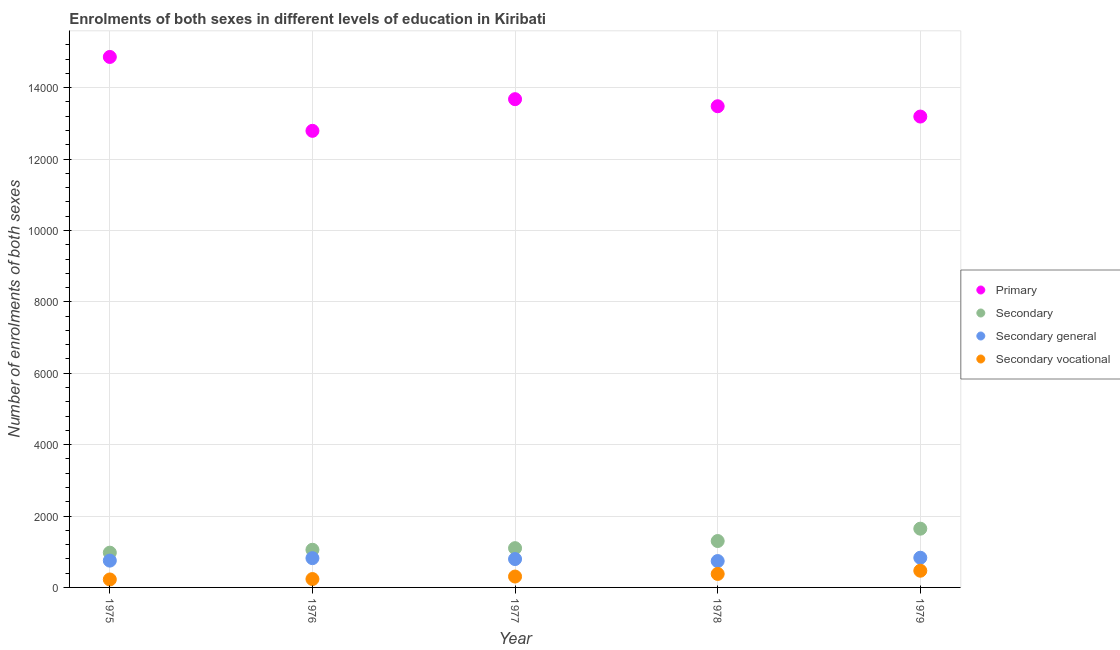What is the number of enrolments in secondary vocational education in 1977?
Your response must be concise. 305. Across all years, what is the maximum number of enrolments in primary education?
Provide a succinct answer. 1.49e+04. Across all years, what is the minimum number of enrolments in secondary general education?
Give a very brief answer. 739. In which year was the number of enrolments in secondary general education maximum?
Keep it short and to the point. 1979. In which year was the number of enrolments in primary education minimum?
Offer a very short reply. 1976. What is the total number of enrolments in primary education in the graph?
Offer a very short reply. 6.80e+04. What is the difference between the number of enrolments in secondary vocational education in 1975 and that in 1978?
Make the answer very short. -155. What is the difference between the number of enrolments in secondary vocational education in 1979 and the number of enrolments in secondary education in 1976?
Offer a terse response. -587. What is the average number of enrolments in secondary general education per year?
Make the answer very short. 787.4. In the year 1977, what is the difference between the number of enrolments in secondary education and number of enrolments in secondary general education?
Your response must be concise. 305. In how many years, is the number of enrolments in secondary general education greater than 9600?
Keep it short and to the point. 0. What is the ratio of the number of enrolments in secondary general education in 1976 to that in 1978?
Make the answer very short. 1.11. Is the difference between the number of enrolments in secondary general education in 1977 and 1979 greater than the difference between the number of enrolments in primary education in 1977 and 1979?
Provide a succinct answer. No. What is the difference between the highest and the second highest number of enrolments in secondary vocational education?
Make the answer very short. 90. What is the difference between the highest and the lowest number of enrolments in secondary vocational education?
Ensure brevity in your answer.  245. In how many years, is the number of enrolments in secondary vocational education greater than the average number of enrolments in secondary vocational education taken over all years?
Your response must be concise. 2. Is it the case that in every year, the sum of the number of enrolments in secondary general education and number of enrolments in secondary education is greater than the sum of number of enrolments in primary education and number of enrolments in secondary vocational education?
Your answer should be very brief. No. Is it the case that in every year, the sum of the number of enrolments in primary education and number of enrolments in secondary education is greater than the number of enrolments in secondary general education?
Give a very brief answer. Yes. Does the number of enrolments in secondary vocational education monotonically increase over the years?
Provide a short and direct response. Yes. Is the number of enrolments in secondary general education strictly less than the number of enrolments in secondary vocational education over the years?
Make the answer very short. No. Are the values on the major ticks of Y-axis written in scientific E-notation?
Keep it short and to the point. No. Does the graph contain grids?
Your answer should be compact. Yes. Where does the legend appear in the graph?
Give a very brief answer. Center right. What is the title of the graph?
Make the answer very short. Enrolments of both sexes in different levels of education in Kiribati. Does "Social Awareness" appear as one of the legend labels in the graph?
Your response must be concise. No. What is the label or title of the X-axis?
Ensure brevity in your answer.  Year. What is the label or title of the Y-axis?
Provide a short and direct response. Number of enrolments of both sexes. What is the Number of enrolments of both sexes in Primary in 1975?
Provide a succinct answer. 1.49e+04. What is the Number of enrolments of both sexes in Secondary in 1975?
Keep it short and to the point. 974. What is the Number of enrolments of both sexes of Secondary general in 1975?
Your response must be concise. 751. What is the Number of enrolments of both sexes in Secondary vocational in 1975?
Offer a very short reply. 223. What is the Number of enrolments of both sexes of Primary in 1976?
Keep it short and to the point. 1.28e+04. What is the Number of enrolments of both sexes in Secondary in 1976?
Your response must be concise. 1055. What is the Number of enrolments of both sexes in Secondary general in 1976?
Keep it short and to the point. 820. What is the Number of enrolments of both sexes in Secondary vocational in 1976?
Keep it short and to the point. 235. What is the Number of enrolments of both sexes in Primary in 1977?
Provide a short and direct response. 1.37e+04. What is the Number of enrolments of both sexes in Secondary in 1977?
Keep it short and to the point. 1100. What is the Number of enrolments of both sexes in Secondary general in 1977?
Your answer should be very brief. 795. What is the Number of enrolments of both sexes in Secondary vocational in 1977?
Give a very brief answer. 305. What is the Number of enrolments of both sexes in Primary in 1978?
Give a very brief answer. 1.35e+04. What is the Number of enrolments of both sexes in Secondary in 1978?
Offer a terse response. 1300. What is the Number of enrolments of both sexes of Secondary general in 1978?
Your response must be concise. 739. What is the Number of enrolments of both sexes of Secondary vocational in 1978?
Offer a very short reply. 378. What is the Number of enrolments of both sexes in Primary in 1979?
Give a very brief answer. 1.32e+04. What is the Number of enrolments of both sexes in Secondary in 1979?
Make the answer very short. 1646. What is the Number of enrolments of both sexes of Secondary general in 1979?
Provide a short and direct response. 832. What is the Number of enrolments of both sexes of Secondary vocational in 1979?
Offer a terse response. 468. Across all years, what is the maximum Number of enrolments of both sexes in Primary?
Your response must be concise. 1.49e+04. Across all years, what is the maximum Number of enrolments of both sexes of Secondary?
Your response must be concise. 1646. Across all years, what is the maximum Number of enrolments of both sexes in Secondary general?
Your answer should be compact. 832. Across all years, what is the maximum Number of enrolments of both sexes of Secondary vocational?
Offer a very short reply. 468. Across all years, what is the minimum Number of enrolments of both sexes of Primary?
Provide a succinct answer. 1.28e+04. Across all years, what is the minimum Number of enrolments of both sexes in Secondary?
Make the answer very short. 974. Across all years, what is the minimum Number of enrolments of both sexes of Secondary general?
Give a very brief answer. 739. Across all years, what is the minimum Number of enrolments of both sexes of Secondary vocational?
Give a very brief answer. 223. What is the total Number of enrolments of both sexes of Primary in the graph?
Provide a short and direct response. 6.80e+04. What is the total Number of enrolments of both sexes of Secondary in the graph?
Offer a very short reply. 6075. What is the total Number of enrolments of both sexes in Secondary general in the graph?
Provide a succinct answer. 3937. What is the total Number of enrolments of both sexes in Secondary vocational in the graph?
Ensure brevity in your answer.  1609. What is the difference between the Number of enrolments of both sexes of Primary in 1975 and that in 1976?
Make the answer very short. 2070. What is the difference between the Number of enrolments of both sexes of Secondary in 1975 and that in 1976?
Make the answer very short. -81. What is the difference between the Number of enrolments of both sexes of Secondary general in 1975 and that in 1976?
Offer a very short reply. -69. What is the difference between the Number of enrolments of both sexes in Primary in 1975 and that in 1977?
Provide a short and direct response. 1183. What is the difference between the Number of enrolments of both sexes in Secondary in 1975 and that in 1977?
Provide a short and direct response. -126. What is the difference between the Number of enrolments of both sexes of Secondary general in 1975 and that in 1977?
Offer a very short reply. -44. What is the difference between the Number of enrolments of both sexes in Secondary vocational in 1975 and that in 1977?
Your answer should be compact. -82. What is the difference between the Number of enrolments of both sexes of Primary in 1975 and that in 1978?
Your answer should be very brief. 1381. What is the difference between the Number of enrolments of both sexes of Secondary in 1975 and that in 1978?
Provide a succinct answer. -326. What is the difference between the Number of enrolments of both sexes of Secondary vocational in 1975 and that in 1978?
Ensure brevity in your answer.  -155. What is the difference between the Number of enrolments of both sexes of Primary in 1975 and that in 1979?
Keep it short and to the point. 1670. What is the difference between the Number of enrolments of both sexes of Secondary in 1975 and that in 1979?
Keep it short and to the point. -672. What is the difference between the Number of enrolments of both sexes in Secondary general in 1975 and that in 1979?
Give a very brief answer. -81. What is the difference between the Number of enrolments of both sexes of Secondary vocational in 1975 and that in 1979?
Your answer should be compact. -245. What is the difference between the Number of enrolments of both sexes of Primary in 1976 and that in 1977?
Offer a very short reply. -887. What is the difference between the Number of enrolments of both sexes of Secondary in 1976 and that in 1977?
Your answer should be compact. -45. What is the difference between the Number of enrolments of both sexes in Secondary general in 1976 and that in 1977?
Provide a succinct answer. 25. What is the difference between the Number of enrolments of both sexes in Secondary vocational in 1976 and that in 1977?
Provide a succinct answer. -70. What is the difference between the Number of enrolments of both sexes in Primary in 1976 and that in 1978?
Offer a very short reply. -689. What is the difference between the Number of enrolments of both sexes in Secondary in 1976 and that in 1978?
Your answer should be very brief. -245. What is the difference between the Number of enrolments of both sexes of Secondary vocational in 1976 and that in 1978?
Keep it short and to the point. -143. What is the difference between the Number of enrolments of both sexes in Primary in 1976 and that in 1979?
Offer a terse response. -400. What is the difference between the Number of enrolments of both sexes in Secondary in 1976 and that in 1979?
Ensure brevity in your answer.  -591. What is the difference between the Number of enrolments of both sexes in Secondary general in 1976 and that in 1979?
Provide a short and direct response. -12. What is the difference between the Number of enrolments of both sexes of Secondary vocational in 1976 and that in 1979?
Keep it short and to the point. -233. What is the difference between the Number of enrolments of both sexes of Primary in 1977 and that in 1978?
Offer a very short reply. 198. What is the difference between the Number of enrolments of both sexes of Secondary in 1977 and that in 1978?
Your answer should be compact. -200. What is the difference between the Number of enrolments of both sexes in Secondary vocational in 1977 and that in 1978?
Offer a terse response. -73. What is the difference between the Number of enrolments of both sexes of Primary in 1977 and that in 1979?
Your answer should be compact. 487. What is the difference between the Number of enrolments of both sexes in Secondary in 1977 and that in 1979?
Give a very brief answer. -546. What is the difference between the Number of enrolments of both sexes in Secondary general in 1977 and that in 1979?
Your answer should be very brief. -37. What is the difference between the Number of enrolments of both sexes in Secondary vocational in 1977 and that in 1979?
Give a very brief answer. -163. What is the difference between the Number of enrolments of both sexes of Primary in 1978 and that in 1979?
Provide a short and direct response. 289. What is the difference between the Number of enrolments of both sexes in Secondary in 1978 and that in 1979?
Provide a short and direct response. -346. What is the difference between the Number of enrolments of both sexes in Secondary general in 1978 and that in 1979?
Your answer should be very brief. -93. What is the difference between the Number of enrolments of both sexes in Secondary vocational in 1978 and that in 1979?
Your answer should be compact. -90. What is the difference between the Number of enrolments of both sexes of Primary in 1975 and the Number of enrolments of both sexes of Secondary in 1976?
Ensure brevity in your answer.  1.38e+04. What is the difference between the Number of enrolments of both sexes of Primary in 1975 and the Number of enrolments of both sexes of Secondary general in 1976?
Ensure brevity in your answer.  1.40e+04. What is the difference between the Number of enrolments of both sexes in Primary in 1975 and the Number of enrolments of both sexes in Secondary vocational in 1976?
Provide a short and direct response. 1.46e+04. What is the difference between the Number of enrolments of both sexes in Secondary in 1975 and the Number of enrolments of both sexes in Secondary general in 1976?
Make the answer very short. 154. What is the difference between the Number of enrolments of both sexes in Secondary in 1975 and the Number of enrolments of both sexes in Secondary vocational in 1976?
Make the answer very short. 739. What is the difference between the Number of enrolments of both sexes in Secondary general in 1975 and the Number of enrolments of both sexes in Secondary vocational in 1976?
Provide a short and direct response. 516. What is the difference between the Number of enrolments of both sexes of Primary in 1975 and the Number of enrolments of both sexes of Secondary in 1977?
Offer a very short reply. 1.38e+04. What is the difference between the Number of enrolments of both sexes of Primary in 1975 and the Number of enrolments of both sexes of Secondary general in 1977?
Give a very brief answer. 1.41e+04. What is the difference between the Number of enrolments of both sexes in Primary in 1975 and the Number of enrolments of both sexes in Secondary vocational in 1977?
Give a very brief answer. 1.46e+04. What is the difference between the Number of enrolments of both sexes in Secondary in 1975 and the Number of enrolments of both sexes in Secondary general in 1977?
Your answer should be compact. 179. What is the difference between the Number of enrolments of both sexes in Secondary in 1975 and the Number of enrolments of both sexes in Secondary vocational in 1977?
Provide a succinct answer. 669. What is the difference between the Number of enrolments of both sexes in Secondary general in 1975 and the Number of enrolments of both sexes in Secondary vocational in 1977?
Your answer should be very brief. 446. What is the difference between the Number of enrolments of both sexes of Primary in 1975 and the Number of enrolments of both sexes of Secondary in 1978?
Provide a succinct answer. 1.36e+04. What is the difference between the Number of enrolments of both sexes of Primary in 1975 and the Number of enrolments of both sexes of Secondary general in 1978?
Your answer should be very brief. 1.41e+04. What is the difference between the Number of enrolments of both sexes in Primary in 1975 and the Number of enrolments of both sexes in Secondary vocational in 1978?
Offer a very short reply. 1.45e+04. What is the difference between the Number of enrolments of both sexes of Secondary in 1975 and the Number of enrolments of both sexes of Secondary general in 1978?
Give a very brief answer. 235. What is the difference between the Number of enrolments of both sexes in Secondary in 1975 and the Number of enrolments of both sexes in Secondary vocational in 1978?
Your response must be concise. 596. What is the difference between the Number of enrolments of both sexes in Secondary general in 1975 and the Number of enrolments of both sexes in Secondary vocational in 1978?
Your response must be concise. 373. What is the difference between the Number of enrolments of both sexes in Primary in 1975 and the Number of enrolments of both sexes in Secondary in 1979?
Offer a terse response. 1.32e+04. What is the difference between the Number of enrolments of both sexes in Primary in 1975 and the Number of enrolments of both sexes in Secondary general in 1979?
Make the answer very short. 1.40e+04. What is the difference between the Number of enrolments of both sexes of Primary in 1975 and the Number of enrolments of both sexes of Secondary vocational in 1979?
Make the answer very short. 1.44e+04. What is the difference between the Number of enrolments of both sexes in Secondary in 1975 and the Number of enrolments of both sexes in Secondary general in 1979?
Keep it short and to the point. 142. What is the difference between the Number of enrolments of both sexes in Secondary in 1975 and the Number of enrolments of both sexes in Secondary vocational in 1979?
Offer a very short reply. 506. What is the difference between the Number of enrolments of both sexes of Secondary general in 1975 and the Number of enrolments of both sexes of Secondary vocational in 1979?
Keep it short and to the point. 283. What is the difference between the Number of enrolments of both sexes of Primary in 1976 and the Number of enrolments of both sexes of Secondary in 1977?
Ensure brevity in your answer.  1.17e+04. What is the difference between the Number of enrolments of both sexes in Primary in 1976 and the Number of enrolments of both sexes in Secondary general in 1977?
Keep it short and to the point. 1.20e+04. What is the difference between the Number of enrolments of both sexes of Primary in 1976 and the Number of enrolments of both sexes of Secondary vocational in 1977?
Ensure brevity in your answer.  1.25e+04. What is the difference between the Number of enrolments of both sexes in Secondary in 1976 and the Number of enrolments of both sexes in Secondary general in 1977?
Your answer should be very brief. 260. What is the difference between the Number of enrolments of both sexes in Secondary in 1976 and the Number of enrolments of both sexes in Secondary vocational in 1977?
Provide a succinct answer. 750. What is the difference between the Number of enrolments of both sexes of Secondary general in 1976 and the Number of enrolments of both sexes of Secondary vocational in 1977?
Your answer should be compact. 515. What is the difference between the Number of enrolments of both sexes of Primary in 1976 and the Number of enrolments of both sexes of Secondary in 1978?
Your response must be concise. 1.15e+04. What is the difference between the Number of enrolments of both sexes of Primary in 1976 and the Number of enrolments of both sexes of Secondary general in 1978?
Provide a short and direct response. 1.21e+04. What is the difference between the Number of enrolments of both sexes in Primary in 1976 and the Number of enrolments of both sexes in Secondary vocational in 1978?
Make the answer very short. 1.24e+04. What is the difference between the Number of enrolments of both sexes in Secondary in 1976 and the Number of enrolments of both sexes in Secondary general in 1978?
Offer a very short reply. 316. What is the difference between the Number of enrolments of both sexes of Secondary in 1976 and the Number of enrolments of both sexes of Secondary vocational in 1978?
Ensure brevity in your answer.  677. What is the difference between the Number of enrolments of both sexes in Secondary general in 1976 and the Number of enrolments of both sexes in Secondary vocational in 1978?
Give a very brief answer. 442. What is the difference between the Number of enrolments of both sexes in Primary in 1976 and the Number of enrolments of both sexes in Secondary in 1979?
Provide a short and direct response. 1.11e+04. What is the difference between the Number of enrolments of both sexes of Primary in 1976 and the Number of enrolments of both sexes of Secondary general in 1979?
Give a very brief answer. 1.20e+04. What is the difference between the Number of enrolments of both sexes in Primary in 1976 and the Number of enrolments of both sexes in Secondary vocational in 1979?
Ensure brevity in your answer.  1.23e+04. What is the difference between the Number of enrolments of both sexes of Secondary in 1976 and the Number of enrolments of both sexes of Secondary general in 1979?
Offer a very short reply. 223. What is the difference between the Number of enrolments of both sexes of Secondary in 1976 and the Number of enrolments of both sexes of Secondary vocational in 1979?
Offer a very short reply. 587. What is the difference between the Number of enrolments of both sexes in Secondary general in 1976 and the Number of enrolments of both sexes in Secondary vocational in 1979?
Provide a succinct answer. 352. What is the difference between the Number of enrolments of both sexes in Primary in 1977 and the Number of enrolments of both sexes in Secondary in 1978?
Offer a terse response. 1.24e+04. What is the difference between the Number of enrolments of both sexes of Primary in 1977 and the Number of enrolments of both sexes of Secondary general in 1978?
Make the answer very short. 1.29e+04. What is the difference between the Number of enrolments of both sexes in Primary in 1977 and the Number of enrolments of both sexes in Secondary vocational in 1978?
Keep it short and to the point. 1.33e+04. What is the difference between the Number of enrolments of both sexes in Secondary in 1977 and the Number of enrolments of both sexes in Secondary general in 1978?
Make the answer very short. 361. What is the difference between the Number of enrolments of both sexes of Secondary in 1977 and the Number of enrolments of both sexes of Secondary vocational in 1978?
Keep it short and to the point. 722. What is the difference between the Number of enrolments of both sexes in Secondary general in 1977 and the Number of enrolments of both sexes in Secondary vocational in 1978?
Make the answer very short. 417. What is the difference between the Number of enrolments of both sexes in Primary in 1977 and the Number of enrolments of both sexes in Secondary in 1979?
Offer a very short reply. 1.20e+04. What is the difference between the Number of enrolments of both sexes in Primary in 1977 and the Number of enrolments of both sexes in Secondary general in 1979?
Your answer should be compact. 1.28e+04. What is the difference between the Number of enrolments of both sexes of Primary in 1977 and the Number of enrolments of both sexes of Secondary vocational in 1979?
Offer a terse response. 1.32e+04. What is the difference between the Number of enrolments of both sexes of Secondary in 1977 and the Number of enrolments of both sexes of Secondary general in 1979?
Give a very brief answer. 268. What is the difference between the Number of enrolments of both sexes of Secondary in 1977 and the Number of enrolments of both sexes of Secondary vocational in 1979?
Offer a terse response. 632. What is the difference between the Number of enrolments of both sexes in Secondary general in 1977 and the Number of enrolments of both sexes in Secondary vocational in 1979?
Your response must be concise. 327. What is the difference between the Number of enrolments of both sexes of Primary in 1978 and the Number of enrolments of both sexes of Secondary in 1979?
Keep it short and to the point. 1.18e+04. What is the difference between the Number of enrolments of both sexes in Primary in 1978 and the Number of enrolments of both sexes in Secondary general in 1979?
Provide a succinct answer. 1.26e+04. What is the difference between the Number of enrolments of both sexes of Primary in 1978 and the Number of enrolments of both sexes of Secondary vocational in 1979?
Provide a succinct answer. 1.30e+04. What is the difference between the Number of enrolments of both sexes in Secondary in 1978 and the Number of enrolments of both sexes in Secondary general in 1979?
Offer a very short reply. 468. What is the difference between the Number of enrolments of both sexes in Secondary in 1978 and the Number of enrolments of both sexes in Secondary vocational in 1979?
Offer a terse response. 832. What is the difference between the Number of enrolments of both sexes of Secondary general in 1978 and the Number of enrolments of both sexes of Secondary vocational in 1979?
Make the answer very short. 271. What is the average Number of enrolments of both sexes of Primary per year?
Offer a very short reply. 1.36e+04. What is the average Number of enrolments of both sexes in Secondary per year?
Your response must be concise. 1215. What is the average Number of enrolments of both sexes in Secondary general per year?
Keep it short and to the point. 787.4. What is the average Number of enrolments of both sexes of Secondary vocational per year?
Your answer should be compact. 321.8. In the year 1975, what is the difference between the Number of enrolments of both sexes in Primary and Number of enrolments of both sexes in Secondary?
Provide a short and direct response. 1.39e+04. In the year 1975, what is the difference between the Number of enrolments of both sexes of Primary and Number of enrolments of both sexes of Secondary general?
Offer a very short reply. 1.41e+04. In the year 1975, what is the difference between the Number of enrolments of both sexes in Primary and Number of enrolments of both sexes in Secondary vocational?
Offer a very short reply. 1.46e+04. In the year 1975, what is the difference between the Number of enrolments of both sexes in Secondary and Number of enrolments of both sexes in Secondary general?
Your answer should be very brief. 223. In the year 1975, what is the difference between the Number of enrolments of both sexes of Secondary and Number of enrolments of both sexes of Secondary vocational?
Give a very brief answer. 751. In the year 1975, what is the difference between the Number of enrolments of both sexes of Secondary general and Number of enrolments of both sexes of Secondary vocational?
Keep it short and to the point. 528. In the year 1976, what is the difference between the Number of enrolments of both sexes in Primary and Number of enrolments of both sexes in Secondary?
Your answer should be very brief. 1.17e+04. In the year 1976, what is the difference between the Number of enrolments of both sexes in Primary and Number of enrolments of both sexes in Secondary general?
Provide a succinct answer. 1.20e+04. In the year 1976, what is the difference between the Number of enrolments of both sexes in Primary and Number of enrolments of both sexes in Secondary vocational?
Give a very brief answer. 1.26e+04. In the year 1976, what is the difference between the Number of enrolments of both sexes in Secondary and Number of enrolments of both sexes in Secondary general?
Provide a succinct answer. 235. In the year 1976, what is the difference between the Number of enrolments of both sexes of Secondary and Number of enrolments of both sexes of Secondary vocational?
Make the answer very short. 820. In the year 1976, what is the difference between the Number of enrolments of both sexes of Secondary general and Number of enrolments of both sexes of Secondary vocational?
Your answer should be compact. 585. In the year 1977, what is the difference between the Number of enrolments of both sexes in Primary and Number of enrolments of both sexes in Secondary?
Ensure brevity in your answer.  1.26e+04. In the year 1977, what is the difference between the Number of enrolments of both sexes of Primary and Number of enrolments of both sexes of Secondary general?
Make the answer very short. 1.29e+04. In the year 1977, what is the difference between the Number of enrolments of both sexes of Primary and Number of enrolments of both sexes of Secondary vocational?
Your response must be concise. 1.34e+04. In the year 1977, what is the difference between the Number of enrolments of both sexes in Secondary and Number of enrolments of both sexes in Secondary general?
Make the answer very short. 305. In the year 1977, what is the difference between the Number of enrolments of both sexes in Secondary and Number of enrolments of both sexes in Secondary vocational?
Keep it short and to the point. 795. In the year 1977, what is the difference between the Number of enrolments of both sexes in Secondary general and Number of enrolments of both sexes in Secondary vocational?
Provide a short and direct response. 490. In the year 1978, what is the difference between the Number of enrolments of both sexes in Primary and Number of enrolments of both sexes in Secondary?
Provide a succinct answer. 1.22e+04. In the year 1978, what is the difference between the Number of enrolments of both sexes of Primary and Number of enrolments of both sexes of Secondary general?
Provide a short and direct response. 1.27e+04. In the year 1978, what is the difference between the Number of enrolments of both sexes in Primary and Number of enrolments of both sexes in Secondary vocational?
Keep it short and to the point. 1.31e+04. In the year 1978, what is the difference between the Number of enrolments of both sexes of Secondary and Number of enrolments of both sexes of Secondary general?
Provide a short and direct response. 561. In the year 1978, what is the difference between the Number of enrolments of both sexes in Secondary and Number of enrolments of both sexes in Secondary vocational?
Offer a terse response. 922. In the year 1978, what is the difference between the Number of enrolments of both sexes in Secondary general and Number of enrolments of both sexes in Secondary vocational?
Keep it short and to the point. 361. In the year 1979, what is the difference between the Number of enrolments of both sexes of Primary and Number of enrolments of both sexes of Secondary?
Give a very brief answer. 1.15e+04. In the year 1979, what is the difference between the Number of enrolments of both sexes in Primary and Number of enrolments of both sexes in Secondary general?
Your answer should be compact. 1.24e+04. In the year 1979, what is the difference between the Number of enrolments of both sexes of Primary and Number of enrolments of both sexes of Secondary vocational?
Provide a succinct answer. 1.27e+04. In the year 1979, what is the difference between the Number of enrolments of both sexes in Secondary and Number of enrolments of both sexes in Secondary general?
Offer a very short reply. 814. In the year 1979, what is the difference between the Number of enrolments of both sexes of Secondary and Number of enrolments of both sexes of Secondary vocational?
Give a very brief answer. 1178. In the year 1979, what is the difference between the Number of enrolments of both sexes in Secondary general and Number of enrolments of both sexes in Secondary vocational?
Ensure brevity in your answer.  364. What is the ratio of the Number of enrolments of both sexes in Primary in 1975 to that in 1976?
Make the answer very short. 1.16. What is the ratio of the Number of enrolments of both sexes of Secondary in 1975 to that in 1976?
Make the answer very short. 0.92. What is the ratio of the Number of enrolments of both sexes of Secondary general in 1975 to that in 1976?
Provide a succinct answer. 0.92. What is the ratio of the Number of enrolments of both sexes in Secondary vocational in 1975 to that in 1976?
Your response must be concise. 0.95. What is the ratio of the Number of enrolments of both sexes in Primary in 1975 to that in 1977?
Offer a terse response. 1.09. What is the ratio of the Number of enrolments of both sexes in Secondary in 1975 to that in 1977?
Give a very brief answer. 0.89. What is the ratio of the Number of enrolments of both sexes in Secondary general in 1975 to that in 1977?
Keep it short and to the point. 0.94. What is the ratio of the Number of enrolments of both sexes in Secondary vocational in 1975 to that in 1977?
Your answer should be compact. 0.73. What is the ratio of the Number of enrolments of both sexes in Primary in 1975 to that in 1978?
Give a very brief answer. 1.1. What is the ratio of the Number of enrolments of both sexes of Secondary in 1975 to that in 1978?
Your response must be concise. 0.75. What is the ratio of the Number of enrolments of both sexes in Secondary general in 1975 to that in 1978?
Make the answer very short. 1.02. What is the ratio of the Number of enrolments of both sexes in Secondary vocational in 1975 to that in 1978?
Ensure brevity in your answer.  0.59. What is the ratio of the Number of enrolments of both sexes in Primary in 1975 to that in 1979?
Provide a short and direct response. 1.13. What is the ratio of the Number of enrolments of both sexes in Secondary in 1975 to that in 1979?
Your answer should be compact. 0.59. What is the ratio of the Number of enrolments of both sexes in Secondary general in 1975 to that in 1979?
Your answer should be very brief. 0.9. What is the ratio of the Number of enrolments of both sexes of Secondary vocational in 1975 to that in 1979?
Provide a short and direct response. 0.48. What is the ratio of the Number of enrolments of both sexes of Primary in 1976 to that in 1977?
Your response must be concise. 0.94. What is the ratio of the Number of enrolments of both sexes in Secondary in 1976 to that in 1977?
Your response must be concise. 0.96. What is the ratio of the Number of enrolments of both sexes of Secondary general in 1976 to that in 1977?
Your response must be concise. 1.03. What is the ratio of the Number of enrolments of both sexes of Secondary vocational in 1976 to that in 1977?
Offer a terse response. 0.77. What is the ratio of the Number of enrolments of both sexes in Primary in 1976 to that in 1978?
Make the answer very short. 0.95. What is the ratio of the Number of enrolments of both sexes in Secondary in 1976 to that in 1978?
Your answer should be compact. 0.81. What is the ratio of the Number of enrolments of both sexes in Secondary general in 1976 to that in 1978?
Your answer should be very brief. 1.11. What is the ratio of the Number of enrolments of both sexes of Secondary vocational in 1976 to that in 1978?
Your answer should be compact. 0.62. What is the ratio of the Number of enrolments of both sexes of Primary in 1976 to that in 1979?
Provide a succinct answer. 0.97. What is the ratio of the Number of enrolments of both sexes in Secondary in 1976 to that in 1979?
Provide a succinct answer. 0.64. What is the ratio of the Number of enrolments of both sexes of Secondary general in 1976 to that in 1979?
Ensure brevity in your answer.  0.99. What is the ratio of the Number of enrolments of both sexes of Secondary vocational in 1976 to that in 1979?
Your answer should be compact. 0.5. What is the ratio of the Number of enrolments of both sexes in Primary in 1977 to that in 1978?
Your answer should be compact. 1.01. What is the ratio of the Number of enrolments of both sexes of Secondary in 1977 to that in 1978?
Make the answer very short. 0.85. What is the ratio of the Number of enrolments of both sexes in Secondary general in 1977 to that in 1978?
Offer a terse response. 1.08. What is the ratio of the Number of enrolments of both sexes in Secondary vocational in 1977 to that in 1978?
Give a very brief answer. 0.81. What is the ratio of the Number of enrolments of both sexes in Primary in 1977 to that in 1979?
Keep it short and to the point. 1.04. What is the ratio of the Number of enrolments of both sexes of Secondary in 1977 to that in 1979?
Keep it short and to the point. 0.67. What is the ratio of the Number of enrolments of both sexes in Secondary general in 1977 to that in 1979?
Provide a short and direct response. 0.96. What is the ratio of the Number of enrolments of both sexes in Secondary vocational in 1977 to that in 1979?
Provide a short and direct response. 0.65. What is the ratio of the Number of enrolments of both sexes of Primary in 1978 to that in 1979?
Keep it short and to the point. 1.02. What is the ratio of the Number of enrolments of both sexes in Secondary in 1978 to that in 1979?
Offer a very short reply. 0.79. What is the ratio of the Number of enrolments of both sexes of Secondary general in 1978 to that in 1979?
Give a very brief answer. 0.89. What is the ratio of the Number of enrolments of both sexes in Secondary vocational in 1978 to that in 1979?
Make the answer very short. 0.81. What is the difference between the highest and the second highest Number of enrolments of both sexes of Primary?
Provide a short and direct response. 1183. What is the difference between the highest and the second highest Number of enrolments of both sexes in Secondary?
Ensure brevity in your answer.  346. What is the difference between the highest and the lowest Number of enrolments of both sexes of Primary?
Provide a succinct answer. 2070. What is the difference between the highest and the lowest Number of enrolments of both sexes in Secondary?
Give a very brief answer. 672. What is the difference between the highest and the lowest Number of enrolments of both sexes of Secondary general?
Make the answer very short. 93. What is the difference between the highest and the lowest Number of enrolments of both sexes of Secondary vocational?
Your answer should be very brief. 245. 